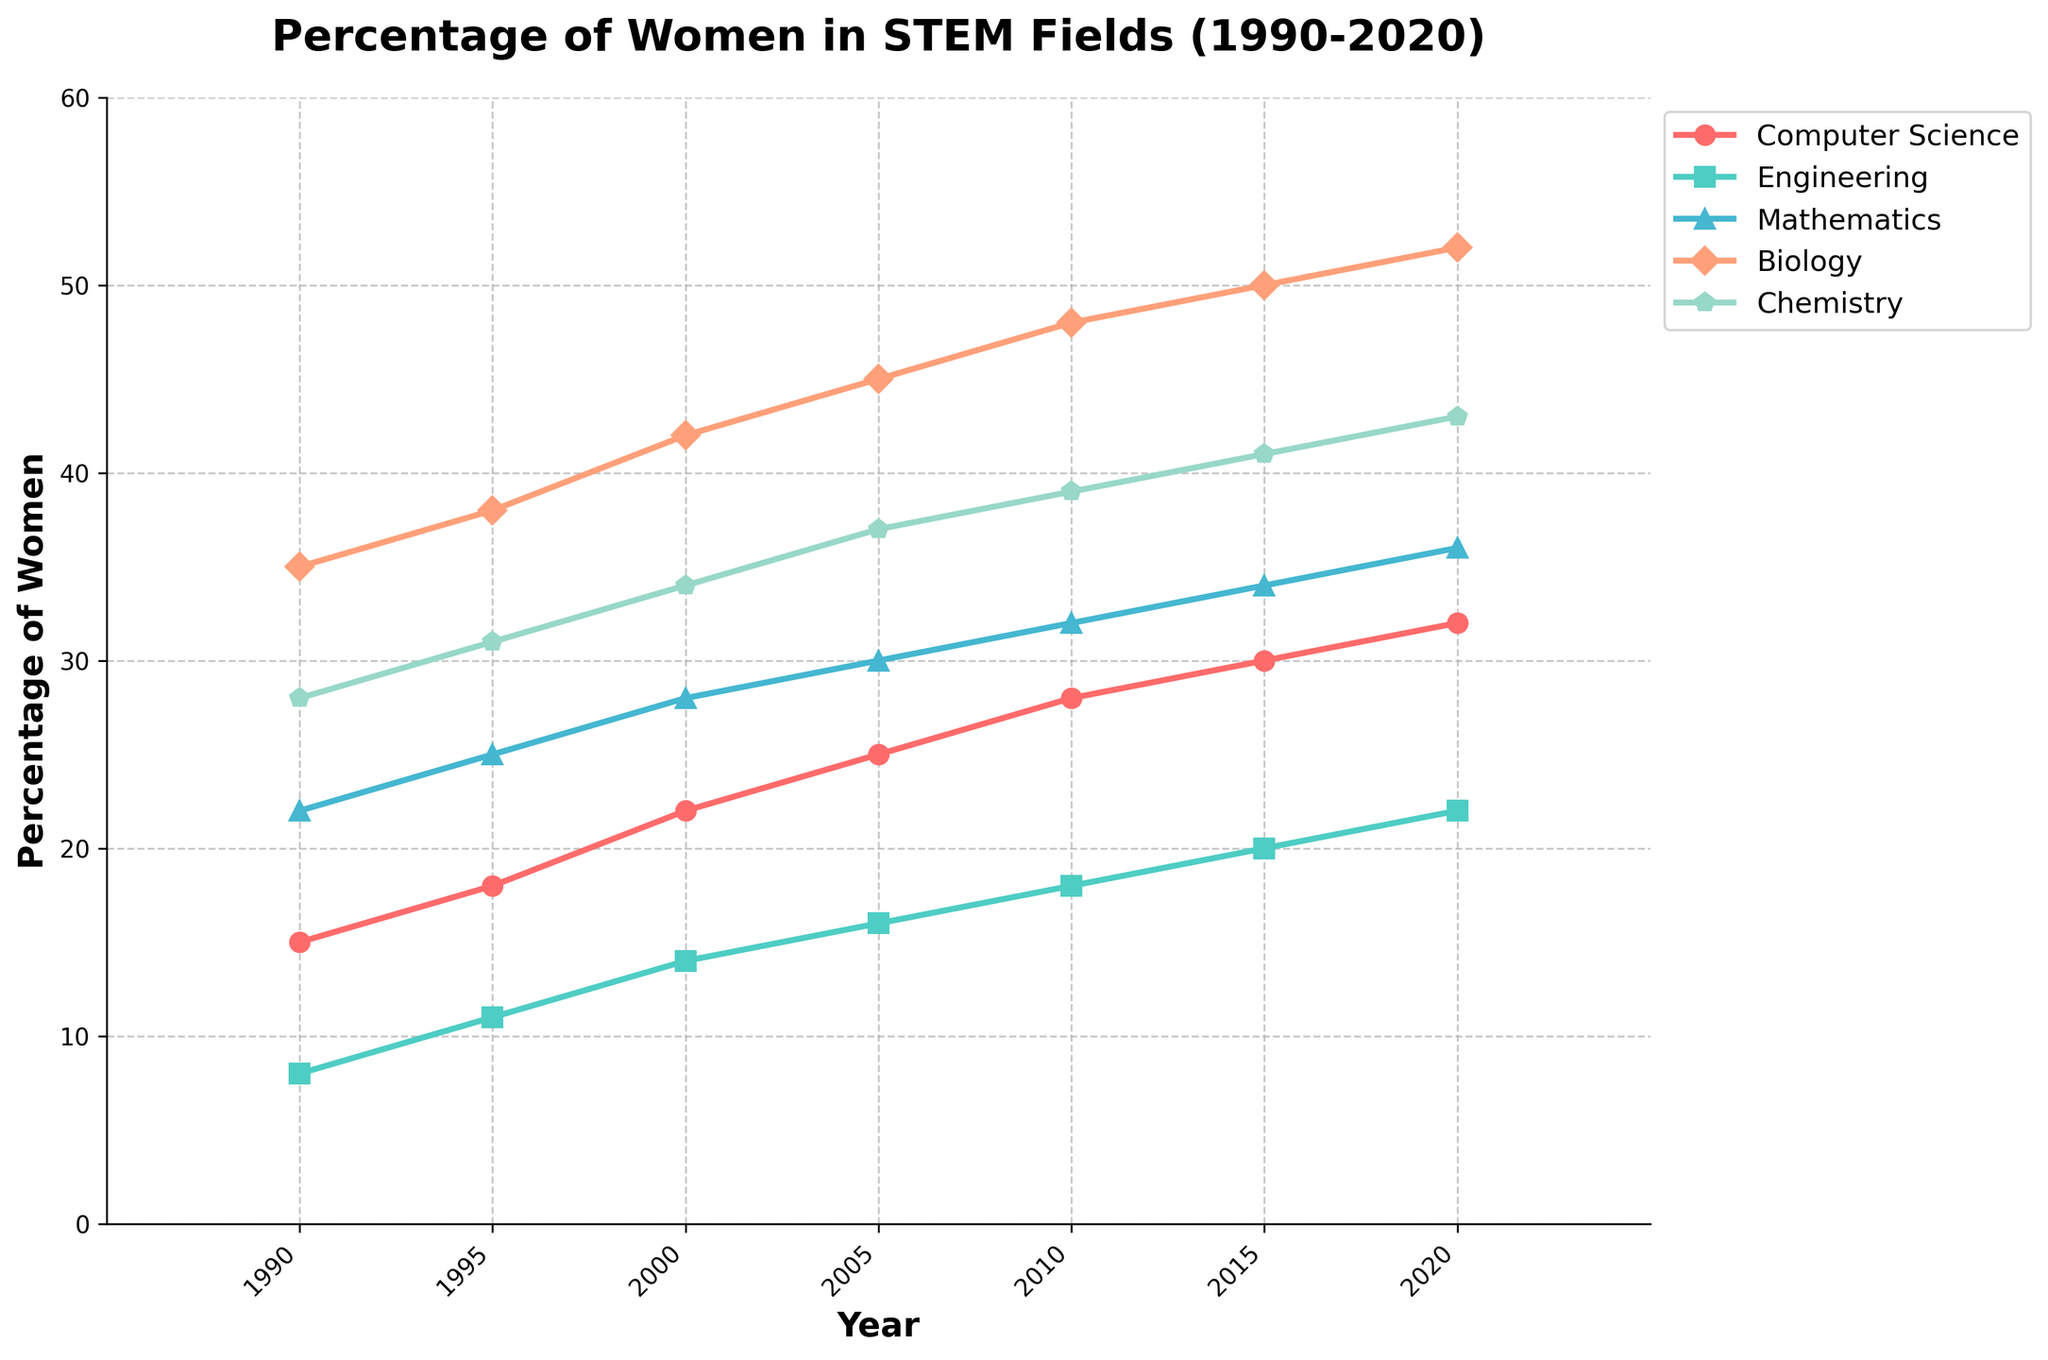What is the percentage increase in women in Computer Science from 1990 to 2020? To find the percentage increase, subtract the initial percentage in 1990 (15%) from the percentage in 2020 (32%), and then divide by the initial percentage and multiply by 100. The calculation is ((32 - 15) / 15) * 100 = 113.33%
Answer: 113.33% Which field had the highest percentage of women in 2020? By observing the figure, the field with the highest percentage of women in 2020 is Biology at 52%.
Answer: Biology In which year did women in Engineering first exceed 15%? By checking the figure, women in Engineering exceeded 15% for the first time in the year 2005 with 16%.
Answer: 2005 Between 1990 and 2020, which field showed the smallest overall percentage increase in women? To find this, calculate the percentage increase for each field from 1990 to 2020 and compare them. The smallest increase is for Chemistry from 28% to 43%. The percentage increase is ((43 - 28) / 28) * 100 = 53.57%.
Answer: Chemistry How does the percentage of women in Mathematics in 2015 compare to that in Chemistry in 2000? By viewing the figure, the percentage of women in Mathematics in 2015 is 34%, and in Chemistry in 2000 is 34%. Their percentages are equal.
Answer: Equal In which year did women in Biology surpass 40% for the first time? Checking the graph, women in Biology surpassed 40% for the first time in the year 2000 with 42%.
Answer: 2000 What is the average percentage of women in the fields of Engineering and Chemistry in the year 2010? To find the average, add the percentages of women in Engineering (18%) and Chemistry (39%) for 2010 and then divide by 2. The calculation is (18 + 39) / 2 = 28.5%.
Answer: 28.5% What is the trend in the percentage of women in Computer Science from 1990 to 2020? Observing the figure, the trend in Computer Science shows a consistent increase from 15% in 1990 to 32% in 2020.
Answer: Increasing Between Biology and Mathematics, which field had a more significant increase in the percentage of women from 1995 to 2000? Calculating the increase for Biology from 1995 (38%) to 2000 (42%) gives an increase of 4%. For Mathematics, from 1995 (25%) to 2000 (28%) gives an increase of 3%. Therefore, Biology had a more significant increase.
Answer: Biology 